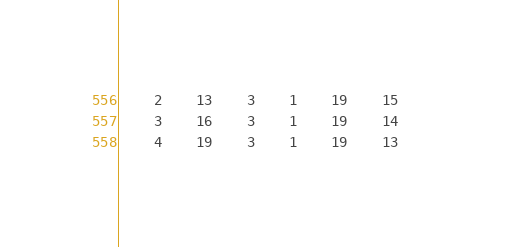<code> <loc_0><loc_0><loc_500><loc_500><_ObjectiveC_>	2	13	3	1	19	15	
	3	16	3	1	19	14	
	4	19	3	1	19	13	</code> 